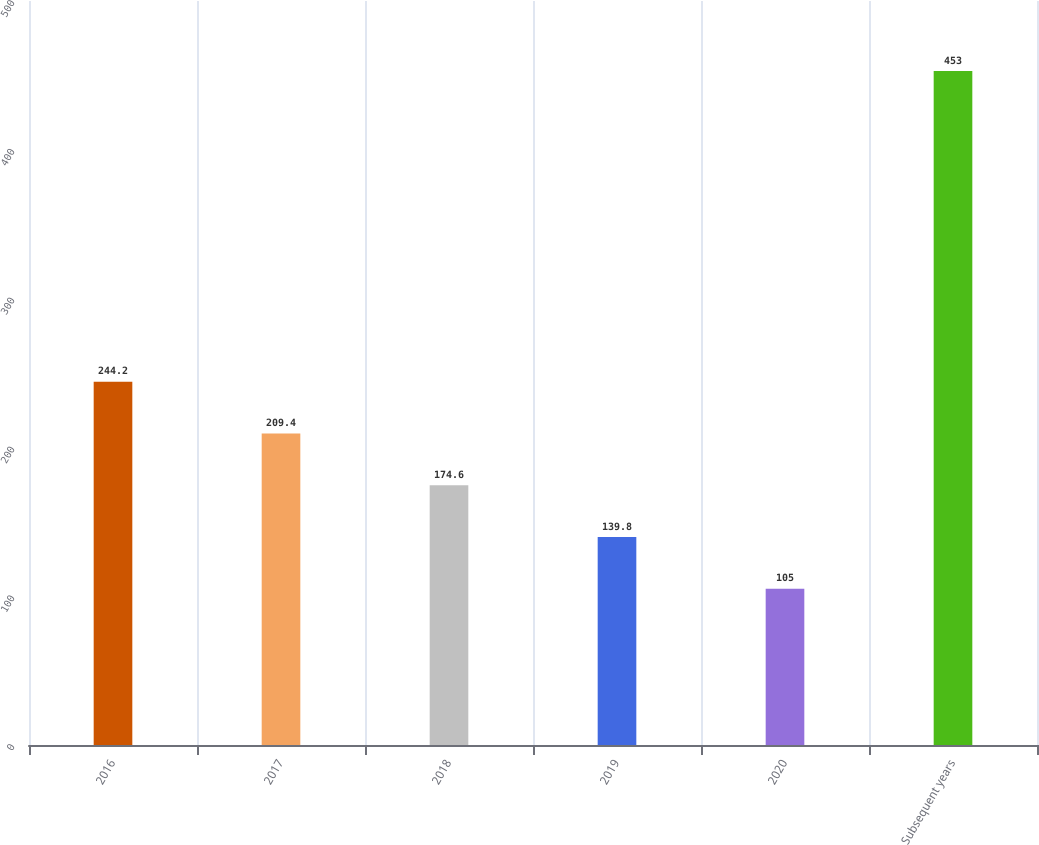Convert chart to OTSL. <chart><loc_0><loc_0><loc_500><loc_500><bar_chart><fcel>2016<fcel>2017<fcel>2018<fcel>2019<fcel>2020<fcel>Subsequent years<nl><fcel>244.2<fcel>209.4<fcel>174.6<fcel>139.8<fcel>105<fcel>453<nl></chart> 